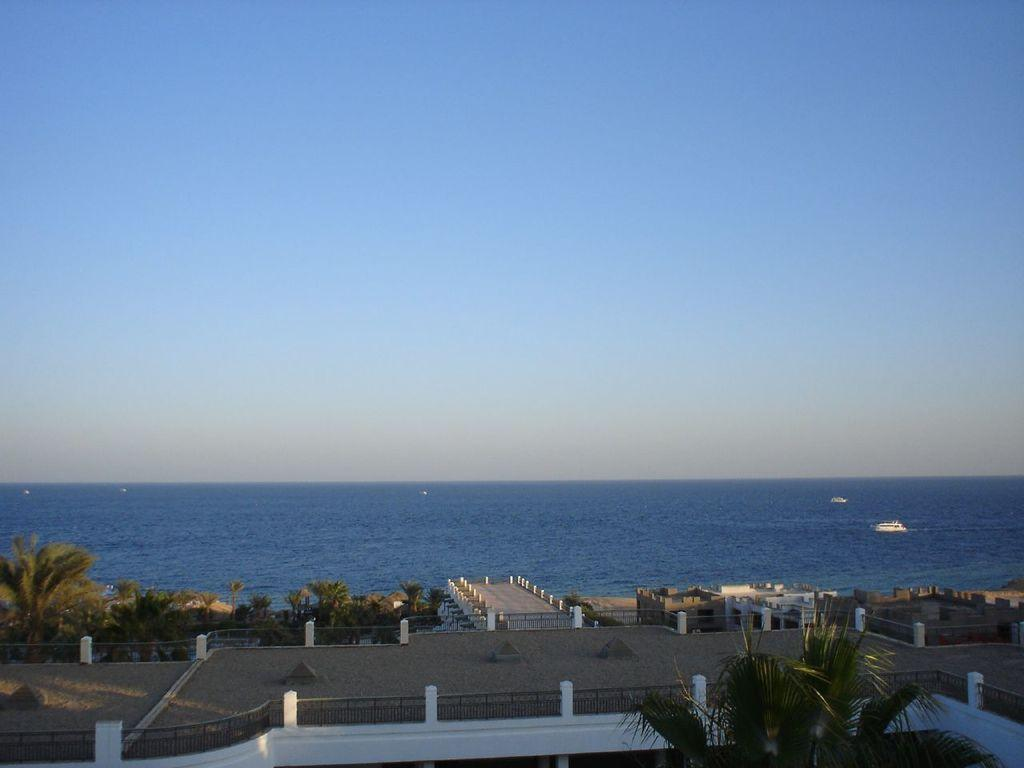What type of structures can be seen in the image? There are houses in the image. What natural elements are present in the image? There are trees and a sea in the image. What can be seen in the background of the image? The sky is visible in the background of the image. What color is the key hanging from the throat of the cub in the image? There is no key or cub present in the image; it features houses, trees, a sea, and the sky. 